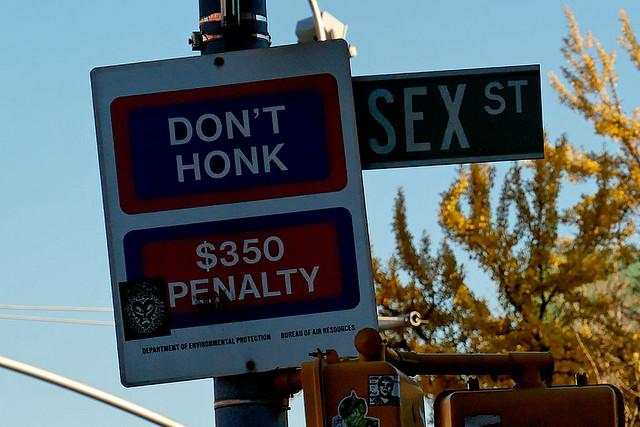What building is at this address?
Answer briefly. Hospital. How many stickers are on the sign?
Short answer required. 1. Is the name of the street inappropriate?
Concise answer only. Yes. What is the penalty for honking?
Be succinct. $350. What are the 2 lines next to the sign?
Be succinct. Power lines. Which way is walnut st?
Short answer required. Left. 